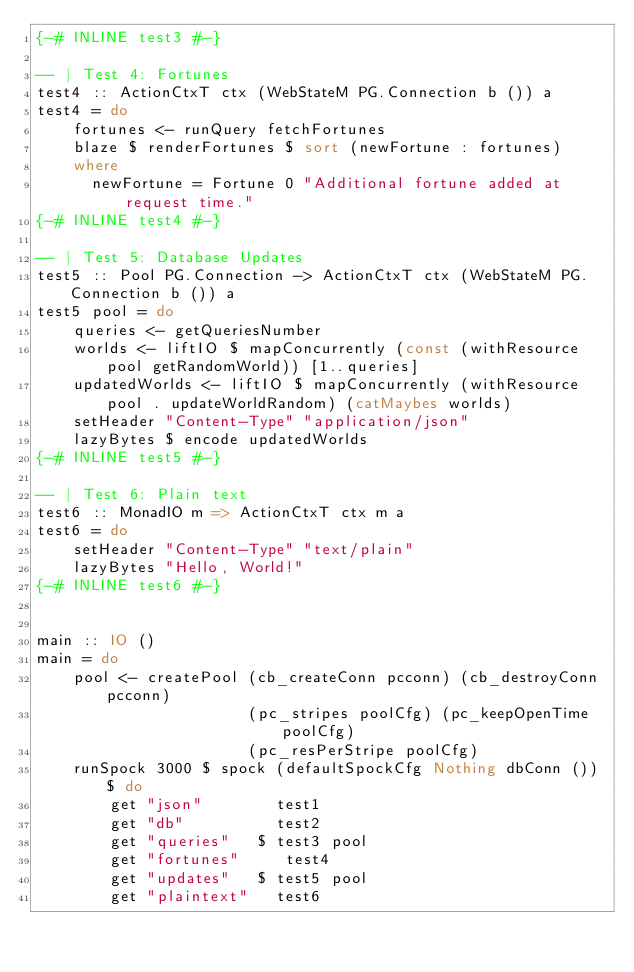Convert code to text. <code><loc_0><loc_0><loc_500><loc_500><_Haskell_>{-# INLINE test3 #-}

-- | Test 4: Fortunes
test4 :: ActionCtxT ctx (WebStateM PG.Connection b ()) a
test4 = do
    fortunes <- runQuery fetchFortunes
    blaze $ renderFortunes $ sort (newFortune : fortunes)
    where
      newFortune = Fortune 0 "Additional fortune added at request time."
{-# INLINE test4 #-}

-- | Test 5: Database Updates
test5 :: Pool PG.Connection -> ActionCtxT ctx (WebStateM PG.Connection b ()) a
test5 pool = do
    queries <- getQueriesNumber
    worlds <- liftIO $ mapConcurrently (const (withResource pool getRandomWorld)) [1..queries]
    updatedWorlds <- liftIO $ mapConcurrently (withResource pool . updateWorldRandom) (catMaybes worlds)
    setHeader "Content-Type" "application/json"
    lazyBytes $ encode updatedWorlds
{-# INLINE test5 #-}

-- | Test 6: Plain text
test6 :: MonadIO m => ActionCtxT ctx m a
test6 = do
    setHeader "Content-Type" "text/plain"
    lazyBytes "Hello, World!"
{-# INLINE test6 #-}


main :: IO ()
main = do
    pool <- createPool (cb_createConn pcconn) (cb_destroyConn pcconn)
                       (pc_stripes poolCfg) (pc_keepOpenTime poolCfg)
                       (pc_resPerStripe poolCfg)
    runSpock 3000 $ spock (defaultSpockCfg Nothing dbConn ()) $ do
        get "json"        test1
        get "db"          test2
        get "queries"   $ test3 pool
        get "fortunes"     test4
        get "updates"   $ test5 pool
        get "plaintext"   test6
</code> 